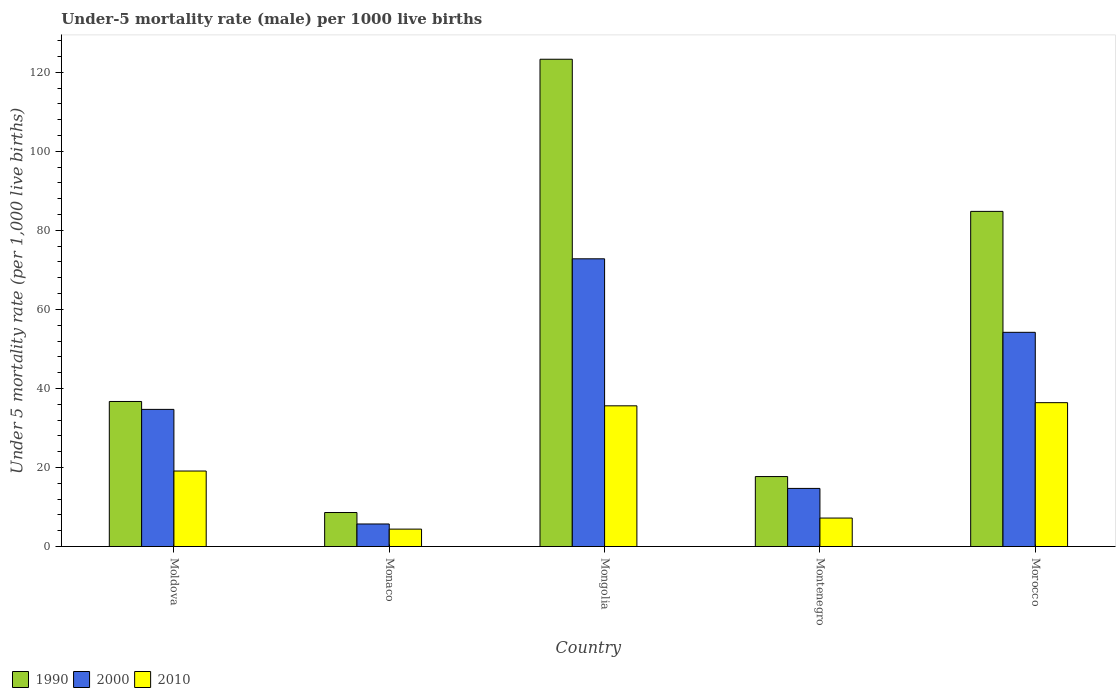How many different coloured bars are there?
Offer a terse response. 3. How many bars are there on the 1st tick from the left?
Provide a short and direct response. 3. How many bars are there on the 2nd tick from the right?
Offer a very short reply. 3. What is the label of the 2nd group of bars from the left?
Make the answer very short. Monaco. In how many cases, is the number of bars for a given country not equal to the number of legend labels?
Provide a short and direct response. 0. Across all countries, what is the maximum under-five mortality rate in 2000?
Your response must be concise. 72.8. Across all countries, what is the minimum under-five mortality rate in 2000?
Your answer should be very brief. 5.7. In which country was the under-five mortality rate in 1990 maximum?
Your response must be concise. Mongolia. In which country was the under-five mortality rate in 2000 minimum?
Give a very brief answer. Monaco. What is the total under-five mortality rate in 2010 in the graph?
Your response must be concise. 102.7. What is the difference between the under-five mortality rate in 2010 in Monaco and that in Mongolia?
Offer a very short reply. -31.2. What is the difference between the under-five mortality rate in 2010 in Moldova and the under-five mortality rate in 1990 in Morocco?
Your response must be concise. -65.7. What is the average under-five mortality rate in 2000 per country?
Give a very brief answer. 36.42. What is the difference between the under-five mortality rate of/in 1990 and under-five mortality rate of/in 2000 in Mongolia?
Your response must be concise. 50.5. In how many countries, is the under-five mortality rate in 2000 greater than 44?
Your answer should be very brief. 2. What is the ratio of the under-five mortality rate in 1990 in Monaco to that in Morocco?
Offer a very short reply. 0.1. What is the difference between the highest and the second highest under-five mortality rate in 2010?
Your answer should be compact. -16.5. Is the sum of the under-five mortality rate in 1990 in Mongolia and Morocco greater than the maximum under-five mortality rate in 2000 across all countries?
Your answer should be compact. Yes. What does the 1st bar from the right in Morocco represents?
Offer a terse response. 2010. Is it the case that in every country, the sum of the under-five mortality rate in 2010 and under-five mortality rate in 1990 is greater than the under-five mortality rate in 2000?
Your answer should be compact. Yes. How many bars are there?
Your answer should be very brief. 15. Are all the bars in the graph horizontal?
Offer a very short reply. No. How many countries are there in the graph?
Give a very brief answer. 5. What is the difference between two consecutive major ticks on the Y-axis?
Provide a short and direct response. 20. Are the values on the major ticks of Y-axis written in scientific E-notation?
Your answer should be very brief. No. What is the title of the graph?
Ensure brevity in your answer.  Under-5 mortality rate (male) per 1000 live births. Does "1999" appear as one of the legend labels in the graph?
Make the answer very short. No. What is the label or title of the Y-axis?
Keep it short and to the point. Under 5 mortality rate (per 1,0 live births). What is the Under 5 mortality rate (per 1,000 live births) in 1990 in Moldova?
Provide a succinct answer. 36.7. What is the Under 5 mortality rate (per 1,000 live births) of 2000 in Moldova?
Your response must be concise. 34.7. What is the Under 5 mortality rate (per 1,000 live births) of 2010 in Moldova?
Ensure brevity in your answer.  19.1. What is the Under 5 mortality rate (per 1,000 live births) of 1990 in Mongolia?
Make the answer very short. 123.3. What is the Under 5 mortality rate (per 1,000 live births) in 2000 in Mongolia?
Ensure brevity in your answer.  72.8. What is the Under 5 mortality rate (per 1,000 live births) of 2010 in Mongolia?
Your answer should be compact. 35.6. What is the Under 5 mortality rate (per 1,000 live births) in 1990 in Montenegro?
Give a very brief answer. 17.7. What is the Under 5 mortality rate (per 1,000 live births) of 2000 in Montenegro?
Offer a terse response. 14.7. What is the Under 5 mortality rate (per 1,000 live births) in 2010 in Montenegro?
Provide a succinct answer. 7.2. What is the Under 5 mortality rate (per 1,000 live births) in 1990 in Morocco?
Keep it short and to the point. 84.8. What is the Under 5 mortality rate (per 1,000 live births) of 2000 in Morocco?
Your response must be concise. 54.2. What is the Under 5 mortality rate (per 1,000 live births) of 2010 in Morocco?
Offer a very short reply. 36.4. Across all countries, what is the maximum Under 5 mortality rate (per 1,000 live births) in 1990?
Give a very brief answer. 123.3. Across all countries, what is the maximum Under 5 mortality rate (per 1,000 live births) of 2000?
Your answer should be very brief. 72.8. Across all countries, what is the maximum Under 5 mortality rate (per 1,000 live births) of 2010?
Make the answer very short. 36.4. Across all countries, what is the minimum Under 5 mortality rate (per 1,000 live births) in 1990?
Ensure brevity in your answer.  8.6. Across all countries, what is the minimum Under 5 mortality rate (per 1,000 live births) of 2010?
Offer a very short reply. 4.4. What is the total Under 5 mortality rate (per 1,000 live births) in 1990 in the graph?
Make the answer very short. 271.1. What is the total Under 5 mortality rate (per 1,000 live births) in 2000 in the graph?
Provide a succinct answer. 182.1. What is the total Under 5 mortality rate (per 1,000 live births) in 2010 in the graph?
Your answer should be very brief. 102.7. What is the difference between the Under 5 mortality rate (per 1,000 live births) of 1990 in Moldova and that in Monaco?
Offer a very short reply. 28.1. What is the difference between the Under 5 mortality rate (per 1,000 live births) in 2000 in Moldova and that in Monaco?
Provide a succinct answer. 29. What is the difference between the Under 5 mortality rate (per 1,000 live births) in 2010 in Moldova and that in Monaco?
Make the answer very short. 14.7. What is the difference between the Under 5 mortality rate (per 1,000 live births) of 1990 in Moldova and that in Mongolia?
Provide a short and direct response. -86.6. What is the difference between the Under 5 mortality rate (per 1,000 live births) in 2000 in Moldova and that in Mongolia?
Provide a succinct answer. -38.1. What is the difference between the Under 5 mortality rate (per 1,000 live births) of 2010 in Moldova and that in Mongolia?
Ensure brevity in your answer.  -16.5. What is the difference between the Under 5 mortality rate (per 1,000 live births) in 1990 in Moldova and that in Montenegro?
Provide a short and direct response. 19. What is the difference between the Under 5 mortality rate (per 1,000 live births) in 2000 in Moldova and that in Montenegro?
Keep it short and to the point. 20. What is the difference between the Under 5 mortality rate (per 1,000 live births) in 1990 in Moldova and that in Morocco?
Provide a succinct answer. -48.1. What is the difference between the Under 5 mortality rate (per 1,000 live births) in 2000 in Moldova and that in Morocco?
Give a very brief answer. -19.5. What is the difference between the Under 5 mortality rate (per 1,000 live births) in 2010 in Moldova and that in Morocco?
Provide a short and direct response. -17.3. What is the difference between the Under 5 mortality rate (per 1,000 live births) of 1990 in Monaco and that in Mongolia?
Ensure brevity in your answer.  -114.7. What is the difference between the Under 5 mortality rate (per 1,000 live births) of 2000 in Monaco and that in Mongolia?
Provide a short and direct response. -67.1. What is the difference between the Under 5 mortality rate (per 1,000 live births) of 2010 in Monaco and that in Mongolia?
Make the answer very short. -31.2. What is the difference between the Under 5 mortality rate (per 1,000 live births) of 1990 in Monaco and that in Morocco?
Provide a short and direct response. -76.2. What is the difference between the Under 5 mortality rate (per 1,000 live births) of 2000 in Monaco and that in Morocco?
Offer a very short reply. -48.5. What is the difference between the Under 5 mortality rate (per 1,000 live births) in 2010 in Monaco and that in Morocco?
Give a very brief answer. -32. What is the difference between the Under 5 mortality rate (per 1,000 live births) of 1990 in Mongolia and that in Montenegro?
Make the answer very short. 105.6. What is the difference between the Under 5 mortality rate (per 1,000 live births) of 2000 in Mongolia and that in Montenegro?
Your answer should be compact. 58.1. What is the difference between the Under 5 mortality rate (per 1,000 live births) of 2010 in Mongolia and that in Montenegro?
Your response must be concise. 28.4. What is the difference between the Under 5 mortality rate (per 1,000 live births) of 1990 in Mongolia and that in Morocco?
Offer a very short reply. 38.5. What is the difference between the Under 5 mortality rate (per 1,000 live births) in 1990 in Montenegro and that in Morocco?
Keep it short and to the point. -67.1. What is the difference between the Under 5 mortality rate (per 1,000 live births) in 2000 in Montenegro and that in Morocco?
Give a very brief answer. -39.5. What is the difference between the Under 5 mortality rate (per 1,000 live births) in 2010 in Montenegro and that in Morocco?
Provide a succinct answer. -29.2. What is the difference between the Under 5 mortality rate (per 1,000 live births) in 1990 in Moldova and the Under 5 mortality rate (per 1,000 live births) in 2000 in Monaco?
Give a very brief answer. 31. What is the difference between the Under 5 mortality rate (per 1,000 live births) in 1990 in Moldova and the Under 5 mortality rate (per 1,000 live births) in 2010 in Monaco?
Provide a short and direct response. 32.3. What is the difference between the Under 5 mortality rate (per 1,000 live births) in 2000 in Moldova and the Under 5 mortality rate (per 1,000 live births) in 2010 in Monaco?
Provide a short and direct response. 30.3. What is the difference between the Under 5 mortality rate (per 1,000 live births) in 1990 in Moldova and the Under 5 mortality rate (per 1,000 live births) in 2000 in Mongolia?
Ensure brevity in your answer.  -36.1. What is the difference between the Under 5 mortality rate (per 1,000 live births) of 1990 in Moldova and the Under 5 mortality rate (per 1,000 live births) of 2010 in Mongolia?
Provide a succinct answer. 1.1. What is the difference between the Under 5 mortality rate (per 1,000 live births) of 1990 in Moldova and the Under 5 mortality rate (per 1,000 live births) of 2010 in Montenegro?
Provide a succinct answer. 29.5. What is the difference between the Under 5 mortality rate (per 1,000 live births) of 2000 in Moldova and the Under 5 mortality rate (per 1,000 live births) of 2010 in Montenegro?
Provide a succinct answer. 27.5. What is the difference between the Under 5 mortality rate (per 1,000 live births) in 1990 in Moldova and the Under 5 mortality rate (per 1,000 live births) in 2000 in Morocco?
Make the answer very short. -17.5. What is the difference between the Under 5 mortality rate (per 1,000 live births) in 1990 in Moldova and the Under 5 mortality rate (per 1,000 live births) in 2010 in Morocco?
Offer a terse response. 0.3. What is the difference between the Under 5 mortality rate (per 1,000 live births) in 1990 in Monaco and the Under 5 mortality rate (per 1,000 live births) in 2000 in Mongolia?
Your answer should be compact. -64.2. What is the difference between the Under 5 mortality rate (per 1,000 live births) of 2000 in Monaco and the Under 5 mortality rate (per 1,000 live births) of 2010 in Mongolia?
Your answer should be very brief. -29.9. What is the difference between the Under 5 mortality rate (per 1,000 live births) of 1990 in Monaco and the Under 5 mortality rate (per 1,000 live births) of 2000 in Montenegro?
Offer a terse response. -6.1. What is the difference between the Under 5 mortality rate (per 1,000 live births) of 1990 in Monaco and the Under 5 mortality rate (per 1,000 live births) of 2010 in Montenegro?
Keep it short and to the point. 1.4. What is the difference between the Under 5 mortality rate (per 1,000 live births) in 1990 in Monaco and the Under 5 mortality rate (per 1,000 live births) in 2000 in Morocco?
Your response must be concise. -45.6. What is the difference between the Under 5 mortality rate (per 1,000 live births) of 1990 in Monaco and the Under 5 mortality rate (per 1,000 live births) of 2010 in Morocco?
Your answer should be compact. -27.8. What is the difference between the Under 5 mortality rate (per 1,000 live births) in 2000 in Monaco and the Under 5 mortality rate (per 1,000 live births) in 2010 in Morocco?
Your answer should be compact. -30.7. What is the difference between the Under 5 mortality rate (per 1,000 live births) of 1990 in Mongolia and the Under 5 mortality rate (per 1,000 live births) of 2000 in Montenegro?
Your response must be concise. 108.6. What is the difference between the Under 5 mortality rate (per 1,000 live births) of 1990 in Mongolia and the Under 5 mortality rate (per 1,000 live births) of 2010 in Montenegro?
Provide a succinct answer. 116.1. What is the difference between the Under 5 mortality rate (per 1,000 live births) of 2000 in Mongolia and the Under 5 mortality rate (per 1,000 live births) of 2010 in Montenegro?
Provide a succinct answer. 65.6. What is the difference between the Under 5 mortality rate (per 1,000 live births) of 1990 in Mongolia and the Under 5 mortality rate (per 1,000 live births) of 2000 in Morocco?
Your answer should be compact. 69.1. What is the difference between the Under 5 mortality rate (per 1,000 live births) of 1990 in Mongolia and the Under 5 mortality rate (per 1,000 live births) of 2010 in Morocco?
Offer a very short reply. 86.9. What is the difference between the Under 5 mortality rate (per 1,000 live births) in 2000 in Mongolia and the Under 5 mortality rate (per 1,000 live births) in 2010 in Morocco?
Your answer should be compact. 36.4. What is the difference between the Under 5 mortality rate (per 1,000 live births) of 1990 in Montenegro and the Under 5 mortality rate (per 1,000 live births) of 2000 in Morocco?
Your answer should be very brief. -36.5. What is the difference between the Under 5 mortality rate (per 1,000 live births) in 1990 in Montenegro and the Under 5 mortality rate (per 1,000 live births) in 2010 in Morocco?
Offer a very short reply. -18.7. What is the difference between the Under 5 mortality rate (per 1,000 live births) of 2000 in Montenegro and the Under 5 mortality rate (per 1,000 live births) of 2010 in Morocco?
Your response must be concise. -21.7. What is the average Under 5 mortality rate (per 1,000 live births) in 1990 per country?
Make the answer very short. 54.22. What is the average Under 5 mortality rate (per 1,000 live births) of 2000 per country?
Your answer should be very brief. 36.42. What is the average Under 5 mortality rate (per 1,000 live births) in 2010 per country?
Ensure brevity in your answer.  20.54. What is the difference between the Under 5 mortality rate (per 1,000 live births) of 1990 and Under 5 mortality rate (per 1,000 live births) of 2010 in Monaco?
Offer a very short reply. 4.2. What is the difference between the Under 5 mortality rate (per 1,000 live births) of 2000 and Under 5 mortality rate (per 1,000 live births) of 2010 in Monaco?
Keep it short and to the point. 1.3. What is the difference between the Under 5 mortality rate (per 1,000 live births) of 1990 and Under 5 mortality rate (per 1,000 live births) of 2000 in Mongolia?
Make the answer very short. 50.5. What is the difference between the Under 5 mortality rate (per 1,000 live births) in 1990 and Under 5 mortality rate (per 1,000 live births) in 2010 in Mongolia?
Your answer should be compact. 87.7. What is the difference between the Under 5 mortality rate (per 1,000 live births) of 2000 and Under 5 mortality rate (per 1,000 live births) of 2010 in Mongolia?
Your response must be concise. 37.2. What is the difference between the Under 5 mortality rate (per 1,000 live births) of 1990 and Under 5 mortality rate (per 1,000 live births) of 2010 in Montenegro?
Offer a terse response. 10.5. What is the difference between the Under 5 mortality rate (per 1,000 live births) of 2000 and Under 5 mortality rate (per 1,000 live births) of 2010 in Montenegro?
Give a very brief answer. 7.5. What is the difference between the Under 5 mortality rate (per 1,000 live births) in 1990 and Under 5 mortality rate (per 1,000 live births) in 2000 in Morocco?
Ensure brevity in your answer.  30.6. What is the difference between the Under 5 mortality rate (per 1,000 live births) of 1990 and Under 5 mortality rate (per 1,000 live births) of 2010 in Morocco?
Offer a very short reply. 48.4. What is the ratio of the Under 5 mortality rate (per 1,000 live births) in 1990 in Moldova to that in Monaco?
Make the answer very short. 4.27. What is the ratio of the Under 5 mortality rate (per 1,000 live births) of 2000 in Moldova to that in Monaco?
Provide a succinct answer. 6.09. What is the ratio of the Under 5 mortality rate (per 1,000 live births) of 2010 in Moldova to that in Monaco?
Keep it short and to the point. 4.34. What is the ratio of the Under 5 mortality rate (per 1,000 live births) in 1990 in Moldova to that in Mongolia?
Provide a succinct answer. 0.3. What is the ratio of the Under 5 mortality rate (per 1,000 live births) in 2000 in Moldova to that in Mongolia?
Your answer should be very brief. 0.48. What is the ratio of the Under 5 mortality rate (per 1,000 live births) in 2010 in Moldova to that in Mongolia?
Give a very brief answer. 0.54. What is the ratio of the Under 5 mortality rate (per 1,000 live births) of 1990 in Moldova to that in Montenegro?
Provide a short and direct response. 2.07. What is the ratio of the Under 5 mortality rate (per 1,000 live births) in 2000 in Moldova to that in Montenegro?
Provide a succinct answer. 2.36. What is the ratio of the Under 5 mortality rate (per 1,000 live births) in 2010 in Moldova to that in Montenegro?
Keep it short and to the point. 2.65. What is the ratio of the Under 5 mortality rate (per 1,000 live births) of 1990 in Moldova to that in Morocco?
Offer a terse response. 0.43. What is the ratio of the Under 5 mortality rate (per 1,000 live births) in 2000 in Moldova to that in Morocco?
Ensure brevity in your answer.  0.64. What is the ratio of the Under 5 mortality rate (per 1,000 live births) in 2010 in Moldova to that in Morocco?
Provide a succinct answer. 0.52. What is the ratio of the Under 5 mortality rate (per 1,000 live births) in 1990 in Monaco to that in Mongolia?
Make the answer very short. 0.07. What is the ratio of the Under 5 mortality rate (per 1,000 live births) of 2000 in Monaco to that in Mongolia?
Provide a succinct answer. 0.08. What is the ratio of the Under 5 mortality rate (per 1,000 live births) in 2010 in Monaco to that in Mongolia?
Provide a short and direct response. 0.12. What is the ratio of the Under 5 mortality rate (per 1,000 live births) of 1990 in Monaco to that in Montenegro?
Your answer should be compact. 0.49. What is the ratio of the Under 5 mortality rate (per 1,000 live births) in 2000 in Monaco to that in Montenegro?
Your answer should be compact. 0.39. What is the ratio of the Under 5 mortality rate (per 1,000 live births) in 2010 in Monaco to that in Montenegro?
Make the answer very short. 0.61. What is the ratio of the Under 5 mortality rate (per 1,000 live births) of 1990 in Monaco to that in Morocco?
Give a very brief answer. 0.1. What is the ratio of the Under 5 mortality rate (per 1,000 live births) in 2000 in Monaco to that in Morocco?
Provide a short and direct response. 0.11. What is the ratio of the Under 5 mortality rate (per 1,000 live births) in 2010 in Monaco to that in Morocco?
Give a very brief answer. 0.12. What is the ratio of the Under 5 mortality rate (per 1,000 live births) of 1990 in Mongolia to that in Montenegro?
Offer a very short reply. 6.97. What is the ratio of the Under 5 mortality rate (per 1,000 live births) of 2000 in Mongolia to that in Montenegro?
Your answer should be very brief. 4.95. What is the ratio of the Under 5 mortality rate (per 1,000 live births) in 2010 in Mongolia to that in Montenegro?
Provide a short and direct response. 4.94. What is the ratio of the Under 5 mortality rate (per 1,000 live births) in 1990 in Mongolia to that in Morocco?
Offer a very short reply. 1.45. What is the ratio of the Under 5 mortality rate (per 1,000 live births) in 2000 in Mongolia to that in Morocco?
Give a very brief answer. 1.34. What is the ratio of the Under 5 mortality rate (per 1,000 live births) in 1990 in Montenegro to that in Morocco?
Offer a terse response. 0.21. What is the ratio of the Under 5 mortality rate (per 1,000 live births) in 2000 in Montenegro to that in Morocco?
Your response must be concise. 0.27. What is the ratio of the Under 5 mortality rate (per 1,000 live births) of 2010 in Montenegro to that in Morocco?
Make the answer very short. 0.2. What is the difference between the highest and the second highest Under 5 mortality rate (per 1,000 live births) in 1990?
Give a very brief answer. 38.5. What is the difference between the highest and the second highest Under 5 mortality rate (per 1,000 live births) of 2000?
Provide a short and direct response. 18.6. What is the difference between the highest and the lowest Under 5 mortality rate (per 1,000 live births) of 1990?
Give a very brief answer. 114.7. What is the difference between the highest and the lowest Under 5 mortality rate (per 1,000 live births) of 2000?
Ensure brevity in your answer.  67.1. What is the difference between the highest and the lowest Under 5 mortality rate (per 1,000 live births) in 2010?
Give a very brief answer. 32. 